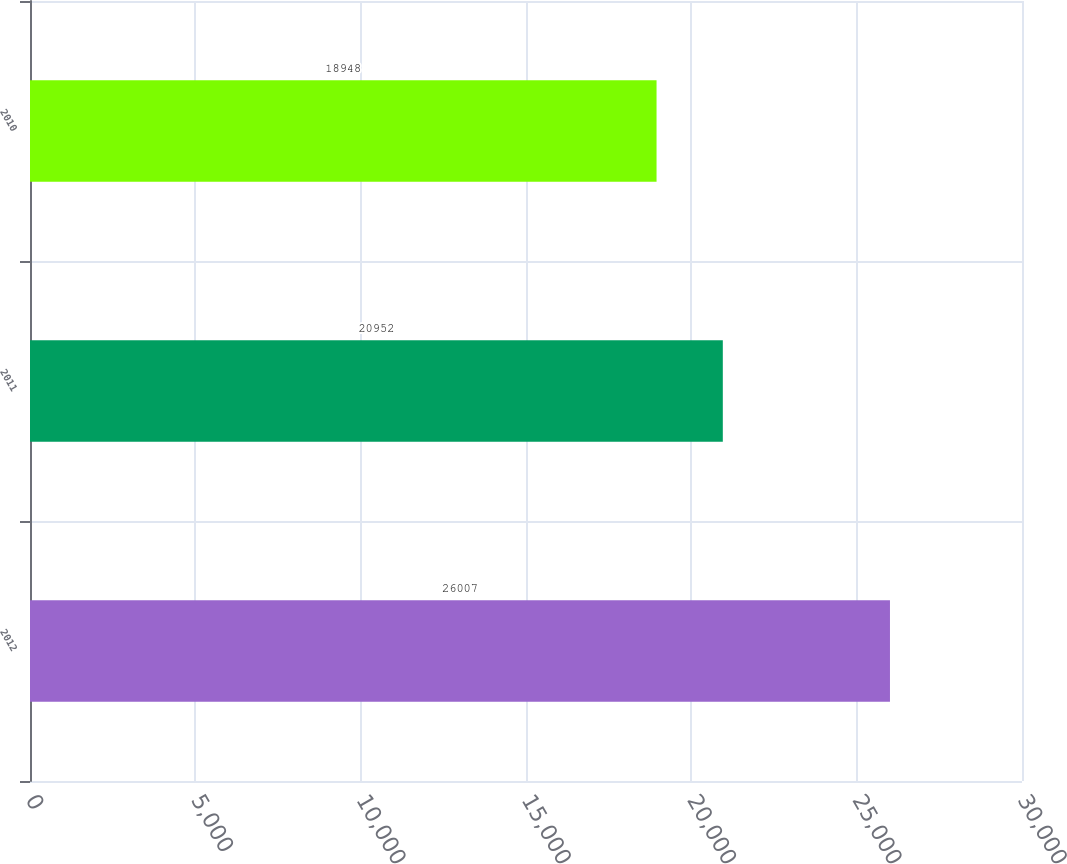<chart> <loc_0><loc_0><loc_500><loc_500><bar_chart><fcel>2012<fcel>2011<fcel>2010<nl><fcel>26007<fcel>20952<fcel>18948<nl></chart> 